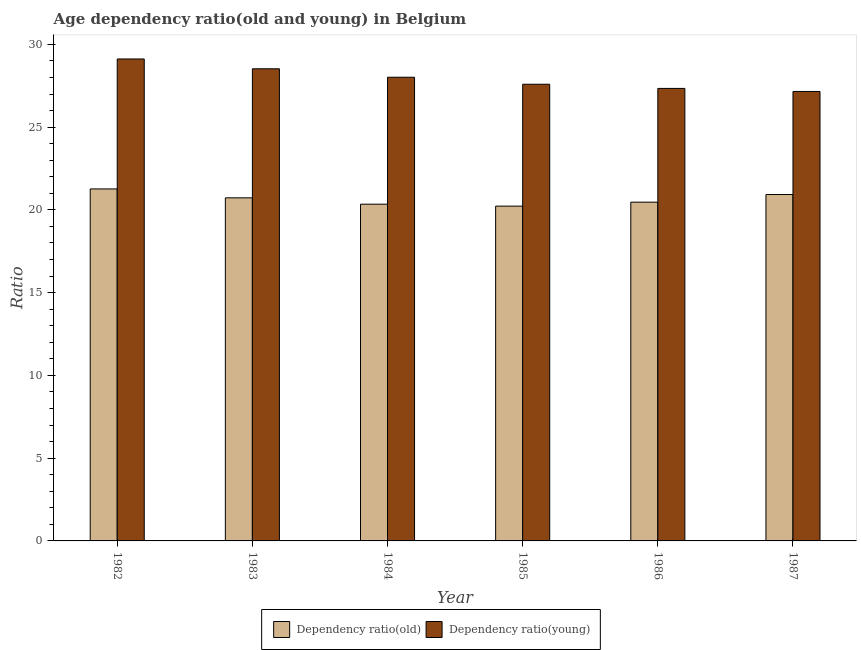Are the number of bars per tick equal to the number of legend labels?
Provide a succinct answer. Yes. Are the number of bars on each tick of the X-axis equal?
Give a very brief answer. Yes. What is the age dependency ratio(old) in 1984?
Your answer should be very brief. 20.35. Across all years, what is the maximum age dependency ratio(young)?
Your response must be concise. 29.12. Across all years, what is the minimum age dependency ratio(old)?
Keep it short and to the point. 20.23. In which year was the age dependency ratio(young) minimum?
Your answer should be very brief. 1987. What is the total age dependency ratio(young) in the graph?
Keep it short and to the point. 167.74. What is the difference between the age dependency ratio(old) in 1986 and that in 1987?
Offer a terse response. -0.46. What is the difference between the age dependency ratio(old) in 1982 and the age dependency ratio(young) in 1983?
Offer a terse response. 0.54. What is the average age dependency ratio(young) per year?
Give a very brief answer. 27.96. In how many years, is the age dependency ratio(old) greater than 17?
Your answer should be compact. 6. What is the ratio of the age dependency ratio(young) in 1982 to that in 1984?
Your answer should be very brief. 1.04. Is the age dependency ratio(old) in 1983 less than that in 1984?
Your answer should be compact. No. Is the difference between the age dependency ratio(old) in 1983 and 1984 greater than the difference between the age dependency ratio(young) in 1983 and 1984?
Your answer should be very brief. No. What is the difference between the highest and the second highest age dependency ratio(young)?
Your response must be concise. 0.59. What is the difference between the highest and the lowest age dependency ratio(old)?
Your answer should be very brief. 1.04. Is the sum of the age dependency ratio(old) in 1985 and 1987 greater than the maximum age dependency ratio(young) across all years?
Provide a succinct answer. Yes. What does the 1st bar from the left in 1984 represents?
Provide a succinct answer. Dependency ratio(old). What does the 1st bar from the right in 1987 represents?
Offer a terse response. Dependency ratio(young). Are all the bars in the graph horizontal?
Give a very brief answer. No. Does the graph contain any zero values?
Give a very brief answer. No. Does the graph contain grids?
Offer a terse response. No. Where does the legend appear in the graph?
Offer a terse response. Bottom center. How many legend labels are there?
Make the answer very short. 2. How are the legend labels stacked?
Offer a very short reply. Horizontal. What is the title of the graph?
Provide a succinct answer. Age dependency ratio(old and young) in Belgium. Does "Arms imports" appear as one of the legend labels in the graph?
Your response must be concise. No. What is the label or title of the Y-axis?
Provide a succinct answer. Ratio. What is the Ratio of Dependency ratio(old) in 1982?
Your response must be concise. 21.27. What is the Ratio in Dependency ratio(young) in 1982?
Ensure brevity in your answer.  29.12. What is the Ratio in Dependency ratio(old) in 1983?
Give a very brief answer. 20.73. What is the Ratio of Dependency ratio(young) in 1983?
Your answer should be very brief. 28.53. What is the Ratio of Dependency ratio(old) in 1984?
Your answer should be compact. 20.35. What is the Ratio of Dependency ratio(young) in 1984?
Offer a terse response. 28.01. What is the Ratio of Dependency ratio(old) in 1985?
Provide a succinct answer. 20.23. What is the Ratio in Dependency ratio(young) in 1985?
Keep it short and to the point. 27.59. What is the Ratio of Dependency ratio(old) in 1986?
Offer a terse response. 20.47. What is the Ratio in Dependency ratio(young) in 1986?
Offer a terse response. 27.34. What is the Ratio of Dependency ratio(old) in 1987?
Offer a terse response. 20.93. What is the Ratio of Dependency ratio(young) in 1987?
Offer a very short reply. 27.15. Across all years, what is the maximum Ratio of Dependency ratio(old)?
Make the answer very short. 21.27. Across all years, what is the maximum Ratio in Dependency ratio(young)?
Make the answer very short. 29.12. Across all years, what is the minimum Ratio of Dependency ratio(old)?
Offer a terse response. 20.23. Across all years, what is the minimum Ratio of Dependency ratio(young)?
Offer a terse response. 27.15. What is the total Ratio in Dependency ratio(old) in the graph?
Provide a short and direct response. 123.96. What is the total Ratio in Dependency ratio(young) in the graph?
Your answer should be compact. 167.74. What is the difference between the Ratio in Dependency ratio(old) in 1982 and that in 1983?
Provide a short and direct response. 0.54. What is the difference between the Ratio of Dependency ratio(young) in 1982 and that in 1983?
Give a very brief answer. 0.59. What is the difference between the Ratio in Dependency ratio(old) in 1982 and that in 1984?
Offer a terse response. 0.92. What is the difference between the Ratio in Dependency ratio(young) in 1982 and that in 1984?
Offer a very short reply. 1.1. What is the difference between the Ratio in Dependency ratio(old) in 1982 and that in 1985?
Your response must be concise. 1.04. What is the difference between the Ratio of Dependency ratio(young) in 1982 and that in 1985?
Offer a very short reply. 1.53. What is the difference between the Ratio in Dependency ratio(old) in 1982 and that in 1986?
Provide a succinct answer. 0.8. What is the difference between the Ratio in Dependency ratio(young) in 1982 and that in 1986?
Provide a succinct answer. 1.78. What is the difference between the Ratio in Dependency ratio(old) in 1982 and that in 1987?
Ensure brevity in your answer.  0.34. What is the difference between the Ratio in Dependency ratio(young) in 1982 and that in 1987?
Offer a terse response. 1.96. What is the difference between the Ratio in Dependency ratio(old) in 1983 and that in 1984?
Offer a very short reply. 0.38. What is the difference between the Ratio of Dependency ratio(young) in 1983 and that in 1984?
Provide a short and direct response. 0.51. What is the difference between the Ratio of Dependency ratio(old) in 1983 and that in 1985?
Your answer should be very brief. 0.5. What is the difference between the Ratio of Dependency ratio(young) in 1983 and that in 1985?
Keep it short and to the point. 0.93. What is the difference between the Ratio in Dependency ratio(old) in 1983 and that in 1986?
Offer a very short reply. 0.26. What is the difference between the Ratio in Dependency ratio(young) in 1983 and that in 1986?
Provide a succinct answer. 1.19. What is the difference between the Ratio in Dependency ratio(old) in 1983 and that in 1987?
Offer a very short reply. -0.2. What is the difference between the Ratio of Dependency ratio(young) in 1983 and that in 1987?
Your response must be concise. 1.37. What is the difference between the Ratio in Dependency ratio(old) in 1984 and that in 1985?
Make the answer very short. 0.12. What is the difference between the Ratio in Dependency ratio(young) in 1984 and that in 1985?
Give a very brief answer. 0.42. What is the difference between the Ratio in Dependency ratio(old) in 1984 and that in 1986?
Your response must be concise. -0.12. What is the difference between the Ratio of Dependency ratio(young) in 1984 and that in 1986?
Your answer should be very brief. 0.67. What is the difference between the Ratio in Dependency ratio(old) in 1984 and that in 1987?
Offer a terse response. -0.58. What is the difference between the Ratio of Dependency ratio(young) in 1984 and that in 1987?
Keep it short and to the point. 0.86. What is the difference between the Ratio in Dependency ratio(old) in 1985 and that in 1986?
Your response must be concise. -0.24. What is the difference between the Ratio of Dependency ratio(young) in 1985 and that in 1986?
Your answer should be very brief. 0.25. What is the difference between the Ratio in Dependency ratio(old) in 1985 and that in 1987?
Give a very brief answer. -0.7. What is the difference between the Ratio of Dependency ratio(young) in 1985 and that in 1987?
Provide a short and direct response. 0.44. What is the difference between the Ratio in Dependency ratio(old) in 1986 and that in 1987?
Offer a very short reply. -0.46. What is the difference between the Ratio in Dependency ratio(young) in 1986 and that in 1987?
Give a very brief answer. 0.18. What is the difference between the Ratio in Dependency ratio(old) in 1982 and the Ratio in Dependency ratio(young) in 1983?
Make the answer very short. -7.26. What is the difference between the Ratio of Dependency ratio(old) in 1982 and the Ratio of Dependency ratio(young) in 1984?
Keep it short and to the point. -6.75. What is the difference between the Ratio in Dependency ratio(old) in 1982 and the Ratio in Dependency ratio(young) in 1985?
Ensure brevity in your answer.  -6.32. What is the difference between the Ratio of Dependency ratio(old) in 1982 and the Ratio of Dependency ratio(young) in 1986?
Your answer should be compact. -6.07. What is the difference between the Ratio of Dependency ratio(old) in 1982 and the Ratio of Dependency ratio(young) in 1987?
Your answer should be very brief. -5.89. What is the difference between the Ratio of Dependency ratio(old) in 1983 and the Ratio of Dependency ratio(young) in 1984?
Your response must be concise. -7.29. What is the difference between the Ratio in Dependency ratio(old) in 1983 and the Ratio in Dependency ratio(young) in 1985?
Offer a terse response. -6.86. What is the difference between the Ratio in Dependency ratio(old) in 1983 and the Ratio in Dependency ratio(young) in 1986?
Provide a succinct answer. -6.61. What is the difference between the Ratio of Dependency ratio(old) in 1983 and the Ratio of Dependency ratio(young) in 1987?
Provide a short and direct response. -6.43. What is the difference between the Ratio in Dependency ratio(old) in 1984 and the Ratio in Dependency ratio(young) in 1985?
Ensure brevity in your answer.  -7.25. What is the difference between the Ratio of Dependency ratio(old) in 1984 and the Ratio of Dependency ratio(young) in 1986?
Ensure brevity in your answer.  -6.99. What is the difference between the Ratio of Dependency ratio(old) in 1984 and the Ratio of Dependency ratio(young) in 1987?
Offer a very short reply. -6.81. What is the difference between the Ratio of Dependency ratio(old) in 1985 and the Ratio of Dependency ratio(young) in 1986?
Offer a terse response. -7.11. What is the difference between the Ratio in Dependency ratio(old) in 1985 and the Ratio in Dependency ratio(young) in 1987?
Ensure brevity in your answer.  -6.93. What is the difference between the Ratio of Dependency ratio(old) in 1986 and the Ratio of Dependency ratio(young) in 1987?
Ensure brevity in your answer.  -6.69. What is the average Ratio of Dependency ratio(old) per year?
Give a very brief answer. 20.66. What is the average Ratio of Dependency ratio(young) per year?
Your answer should be very brief. 27.96. In the year 1982, what is the difference between the Ratio of Dependency ratio(old) and Ratio of Dependency ratio(young)?
Offer a terse response. -7.85. In the year 1983, what is the difference between the Ratio in Dependency ratio(old) and Ratio in Dependency ratio(young)?
Offer a very short reply. -7.8. In the year 1984, what is the difference between the Ratio of Dependency ratio(old) and Ratio of Dependency ratio(young)?
Ensure brevity in your answer.  -7.67. In the year 1985, what is the difference between the Ratio in Dependency ratio(old) and Ratio in Dependency ratio(young)?
Provide a succinct answer. -7.36. In the year 1986, what is the difference between the Ratio of Dependency ratio(old) and Ratio of Dependency ratio(young)?
Provide a succinct answer. -6.87. In the year 1987, what is the difference between the Ratio of Dependency ratio(old) and Ratio of Dependency ratio(young)?
Give a very brief answer. -6.23. What is the ratio of the Ratio of Dependency ratio(old) in 1982 to that in 1983?
Keep it short and to the point. 1.03. What is the ratio of the Ratio in Dependency ratio(young) in 1982 to that in 1983?
Offer a terse response. 1.02. What is the ratio of the Ratio in Dependency ratio(old) in 1982 to that in 1984?
Your response must be concise. 1.05. What is the ratio of the Ratio of Dependency ratio(young) in 1982 to that in 1984?
Your response must be concise. 1.04. What is the ratio of the Ratio in Dependency ratio(old) in 1982 to that in 1985?
Offer a very short reply. 1.05. What is the ratio of the Ratio in Dependency ratio(young) in 1982 to that in 1985?
Offer a terse response. 1.06. What is the ratio of the Ratio in Dependency ratio(old) in 1982 to that in 1986?
Make the answer very short. 1.04. What is the ratio of the Ratio in Dependency ratio(young) in 1982 to that in 1986?
Offer a very short reply. 1.06. What is the ratio of the Ratio of Dependency ratio(old) in 1982 to that in 1987?
Keep it short and to the point. 1.02. What is the ratio of the Ratio in Dependency ratio(young) in 1982 to that in 1987?
Give a very brief answer. 1.07. What is the ratio of the Ratio in Dependency ratio(old) in 1983 to that in 1984?
Keep it short and to the point. 1.02. What is the ratio of the Ratio of Dependency ratio(young) in 1983 to that in 1984?
Keep it short and to the point. 1.02. What is the ratio of the Ratio in Dependency ratio(old) in 1983 to that in 1985?
Give a very brief answer. 1.02. What is the ratio of the Ratio in Dependency ratio(young) in 1983 to that in 1985?
Your response must be concise. 1.03. What is the ratio of the Ratio of Dependency ratio(old) in 1983 to that in 1986?
Your answer should be compact. 1.01. What is the ratio of the Ratio in Dependency ratio(young) in 1983 to that in 1986?
Your response must be concise. 1.04. What is the ratio of the Ratio of Dependency ratio(young) in 1983 to that in 1987?
Ensure brevity in your answer.  1.05. What is the ratio of the Ratio of Dependency ratio(old) in 1984 to that in 1985?
Provide a succinct answer. 1.01. What is the ratio of the Ratio of Dependency ratio(young) in 1984 to that in 1985?
Your response must be concise. 1.02. What is the ratio of the Ratio in Dependency ratio(young) in 1984 to that in 1986?
Make the answer very short. 1.02. What is the ratio of the Ratio of Dependency ratio(old) in 1984 to that in 1987?
Provide a short and direct response. 0.97. What is the ratio of the Ratio of Dependency ratio(young) in 1984 to that in 1987?
Your answer should be very brief. 1.03. What is the ratio of the Ratio in Dependency ratio(old) in 1985 to that in 1986?
Keep it short and to the point. 0.99. What is the ratio of the Ratio of Dependency ratio(young) in 1985 to that in 1986?
Ensure brevity in your answer.  1.01. What is the ratio of the Ratio of Dependency ratio(old) in 1985 to that in 1987?
Your response must be concise. 0.97. What is the ratio of the Ratio in Dependency ratio(young) in 1985 to that in 1987?
Give a very brief answer. 1.02. What is the ratio of the Ratio in Dependency ratio(old) in 1986 to that in 1987?
Ensure brevity in your answer.  0.98. What is the ratio of the Ratio of Dependency ratio(young) in 1986 to that in 1987?
Provide a short and direct response. 1.01. What is the difference between the highest and the second highest Ratio of Dependency ratio(old)?
Your answer should be very brief. 0.34. What is the difference between the highest and the second highest Ratio of Dependency ratio(young)?
Offer a terse response. 0.59. What is the difference between the highest and the lowest Ratio of Dependency ratio(old)?
Offer a terse response. 1.04. What is the difference between the highest and the lowest Ratio of Dependency ratio(young)?
Provide a succinct answer. 1.96. 